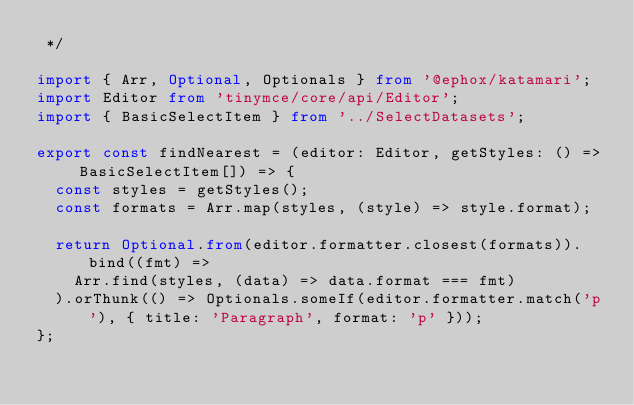Convert code to text. <code><loc_0><loc_0><loc_500><loc_500><_TypeScript_> */

import { Arr, Optional, Optionals } from '@ephox/katamari';
import Editor from 'tinymce/core/api/Editor';
import { BasicSelectItem } from '../SelectDatasets';

export const findNearest = (editor: Editor, getStyles: () => BasicSelectItem[]) => {
  const styles = getStyles();
  const formats = Arr.map(styles, (style) => style.format);

  return Optional.from(editor.formatter.closest(formats)).bind((fmt) =>
    Arr.find(styles, (data) => data.format === fmt)
  ).orThunk(() => Optionals.someIf(editor.formatter.match('p'), { title: 'Paragraph', format: 'p' }));
};
</code> 